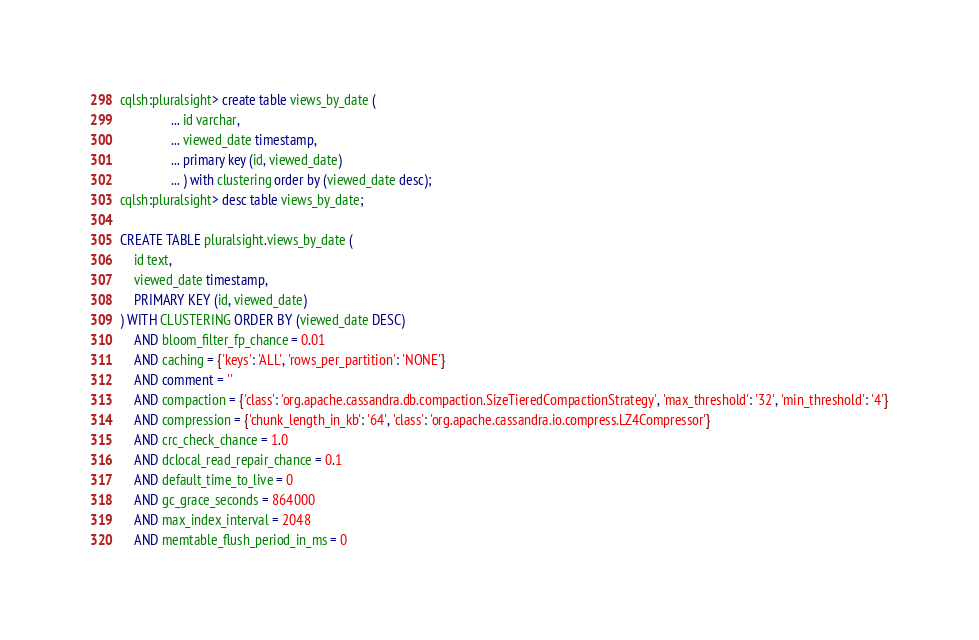<code> <loc_0><loc_0><loc_500><loc_500><_SQL_>cqlsh:pluralsight> create table views_by_date (
               ... id varchar,
               ... viewed_date timestamp,
               ... primary key (id, viewed_date)
               ... ) with clustering order by (viewed_date desc);
cqlsh:pluralsight> desc table views_by_date;

CREATE TABLE pluralsight.views_by_date (
    id text,
    viewed_date timestamp,
    PRIMARY KEY (id, viewed_date)
) WITH CLUSTERING ORDER BY (viewed_date DESC)
    AND bloom_filter_fp_chance = 0.01
    AND caching = {'keys': 'ALL', 'rows_per_partition': 'NONE'}
    AND comment = ''
    AND compaction = {'class': 'org.apache.cassandra.db.compaction.SizeTieredCompactionStrategy', 'max_threshold': '32', 'min_threshold': '4'}
    AND compression = {'chunk_length_in_kb': '64', 'class': 'org.apache.cassandra.io.compress.LZ4Compressor'}
    AND crc_check_chance = 1.0
    AND dclocal_read_repair_chance = 0.1
    AND default_time_to_live = 0
    AND gc_grace_seconds = 864000
    AND max_index_interval = 2048
    AND memtable_flush_period_in_ms = 0</code> 